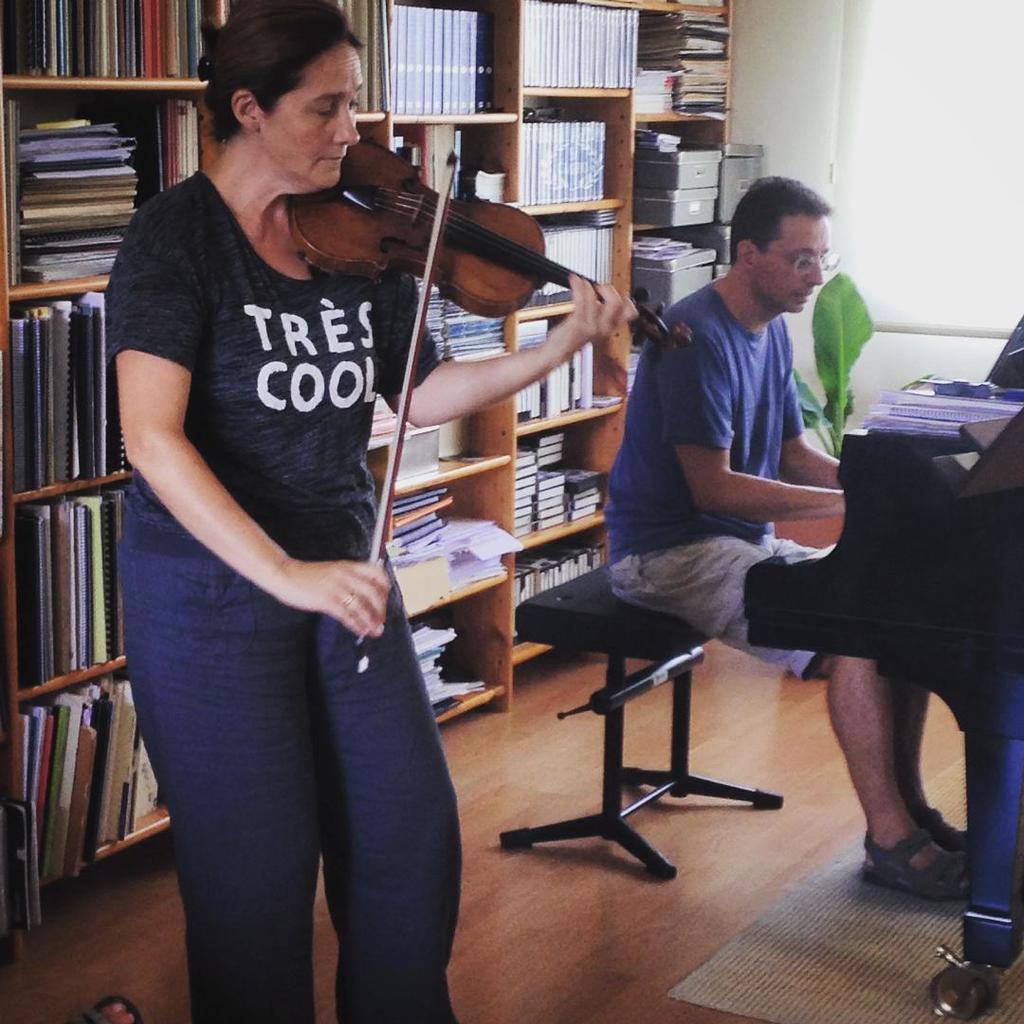Can you describe this image briefly? In this picture we can see a woman who is playing guitar. Here we can see a man who is sitting on the chair. On the background there is a rack and there are some books. This is floor and there is a wall. 